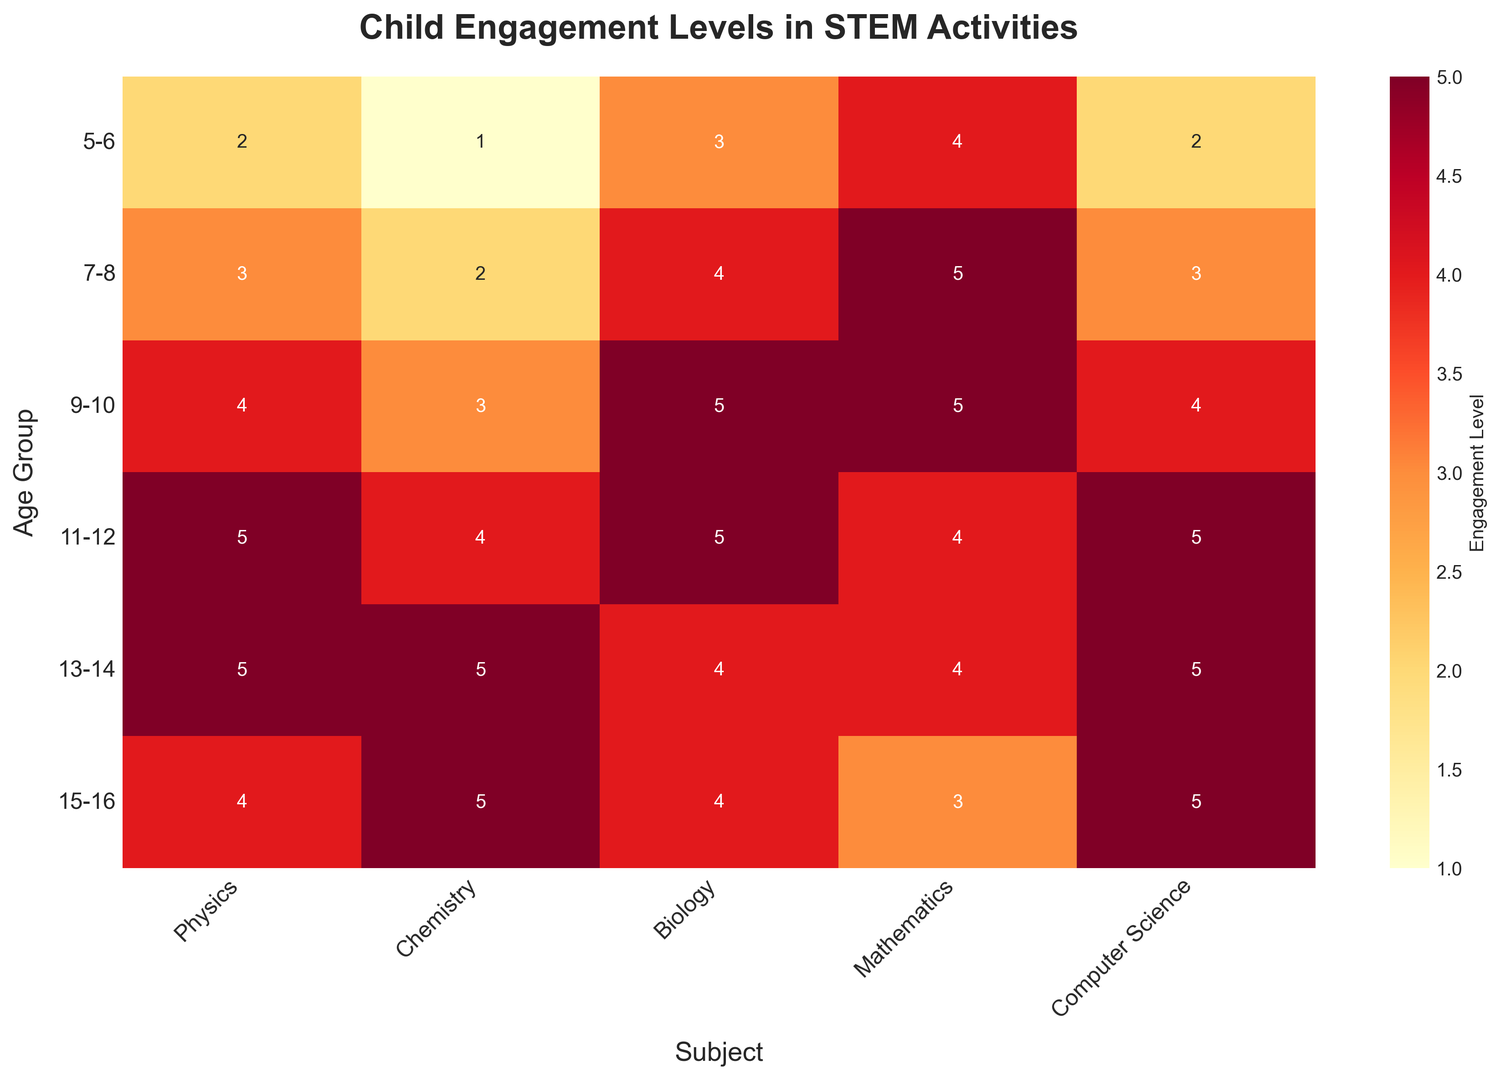What's the average engagement level for Biology across all age groups? To find the average engagement level for Biology, sum the engagement levels for each age group and divide by the number of age groups. The values for Biology are 3, 4, 5, 5, 4, and 4. Summing these values gives 25. There are 6 age groups, so the average is 25/6.
Answer: 4.17 Which subject has the highest engagement level for the 7-8 age group? For the 7-8 age group, compare the engagement levels across all subjects. The values are Physics: 3, Chemistry: 2, Biology: 4, Mathematics: 5, Computer Science: 3. Mathematics has the highest engagement level.
Answer: Mathematics Is the engagement level in Physics for the 13-14 age group higher than in Chemistry for the same age group? Check the engagement levels for the 13-14 age group: Physics is 5 and Chemistry is 5. Compare the two values.
Answer: No Which age group has the highest engagement level in Computer Science? Compare the engagement levels in Computer Science across all age groups. The data points are 2, 3, 4, 5, 5, and 5. The 11-12, 13-14, and 15-16 age groups have the highest engagement level at 5.
Answer: 11-12, 13-14, 15-16 Does engagement in Mathematics increase as age increases from 5-6 to 9-10? Compare the engagement levels in Mathematics for the age groups 5-6, 7-8, and 9-10. The values are 4, 5, and 5. Since 4 < 5 and 5 = 5, engagement increases or remains constant.
Answer: Yes What is the total engagement level across all age groups for Chemistry? Sum the engagement levels for Chemistry across all age groups: 1, 2, 3, 4, 5, and 5. The total is 1+2+3+4+5+5=20.
Answer: 20 Which age group has the lowest engagement level in Chemistry? Compare the engagement levels for all age groups in Chemistry. The values are 1, 2, 3, 4, 5, and 5. The lowest engagement level is 1, which corresponds to the 5-6 age group.
Answer: 5-6 What's the difference in engagement levels between Biology and Computer Science for the 9-10 age group? For the 9-10 age group, the engagement levels are 5 for Biology and 4 for Computer Science. Subtract the Computer Science engagement level from the Biology engagement level: 5 - 4 = 1.
Answer: 1 Is the overall engagement in STEM activities highest in the 11-12 age group compared to others? Calculate the sum of engagement levels for all subjects in each age group. For 11-12: 5+4+5+4+5=23; compare this with the sums for all other age groups: 5-6: 12, 7-8: 17, 9-10: 21, 13-14: 23, 15-16: 21. The 11-12 age group ties with the 13-14 group for the highest sum.
Answer: No Which subject shows a decreasing trend in engagement levels after the age group 11-12? Observe the trend of engagement levels for all subjects starting from the age group 11-12 to 15-16: Physics trends from 5 to 4; Chemistry increases; Biology decreases from 5 to 4; Mathematics decreases from 4 to 3; Computer Science remains constant. So, Physics, Biology, and Mathematics show decreasing trends.
Answer: Physics, Biology, Mathematics 